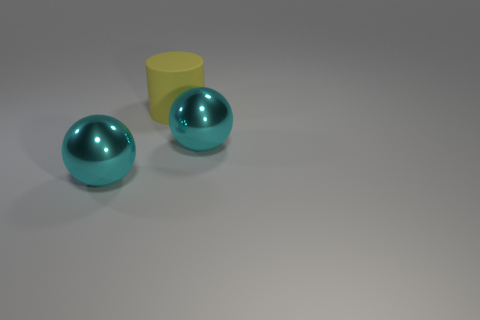Are there any other yellow objects that have the same shape as the yellow object?
Provide a succinct answer. No. There is a large rubber object; does it have the same color as the metal sphere that is to the left of the large yellow rubber cylinder?
Give a very brief answer. No. There is a big thing to the right of the big rubber object; how many yellow cylinders are on the left side of it?
Provide a short and direct response. 1. Is there a gray metallic cube of the same size as the yellow matte cylinder?
Your answer should be compact. No. Does the yellow cylinder have the same material as the big cyan sphere on the left side of the matte thing?
Offer a very short reply. No. There is a yellow thing that is behind the metal object that is on the right side of the large yellow matte object; what number of things are in front of it?
Ensure brevity in your answer.  2. Is the shape of the matte object the same as the big shiny thing that is right of the big cylinder?
Make the answer very short. No. There is a large object behind the big ball that is on the right side of the object that is on the left side of the big yellow rubber cylinder; what is it made of?
Provide a short and direct response. Rubber. What is the material of the yellow thing?
Provide a succinct answer. Rubber. What number of other things are made of the same material as the large cylinder?
Provide a short and direct response. 0. 